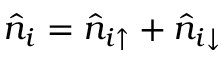Convert formula to latex. <formula><loc_0><loc_0><loc_500><loc_500>\hat { n } _ { i } = \hat { n } _ { i \uparrow } + \hat { n } _ { i \downarrow }</formula> 